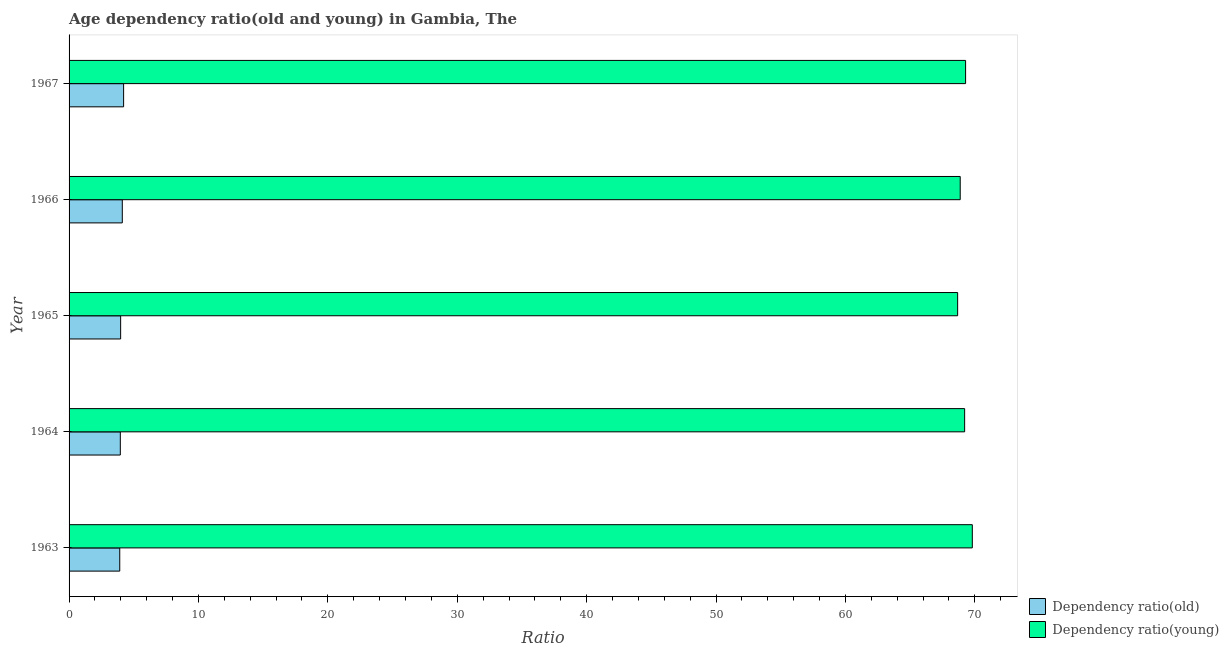How many different coloured bars are there?
Keep it short and to the point. 2. How many groups of bars are there?
Provide a succinct answer. 5. What is the label of the 3rd group of bars from the top?
Make the answer very short. 1965. In how many cases, is the number of bars for a given year not equal to the number of legend labels?
Your response must be concise. 0. What is the age dependency ratio(young) in 1966?
Your answer should be compact. 68.87. Across all years, what is the maximum age dependency ratio(young)?
Your answer should be very brief. 69.81. Across all years, what is the minimum age dependency ratio(old)?
Keep it short and to the point. 3.92. In which year was the age dependency ratio(old) maximum?
Your answer should be compact. 1967. What is the total age dependency ratio(young) in the graph?
Provide a succinct answer. 345.86. What is the difference between the age dependency ratio(old) in 1965 and that in 1966?
Provide a short and direct response. -0.13. What is the difference between the age dependency ratio(young) in 1963 and the age dependency ratio(old) in 1965?
Ensure brevity in your answer.  65.82. What is the average age dependency ratio(old) per year?
Your answer should be very brief. 4.04. In the year 1963, what is the difference between the age dependency ratio(old) and age dependency ratio(young)?
Your response must be concise. -65.89. In how many years, is the age dependency ratio(old) greater than 16 ?
Keep it short and to the point. 0. Is the age dependency ratio(young) in 1964 less than that in 1966?
Your answer should be compact. No. Is the difference between the age dependency ratio(young) in 1964 and 1966 greater than the difference between the age dependency ratio(old) in 1964 and 1966?
Ensure brevity in your answer.  Yes. What is the difference between the highest and the second highest age dependency ratio(old)?
Offer a very short reply. 0.1. In how many years, is the age dependency ratio(old) greater than the average age dependency ratio(old) taken over all years?
Provide a short and direct response. 2. What does the 2nd bar from the top in 1966 represents?
Make the answer very short. Dependency ratio(old). What does the 1st bar from the bottom in 1964 represents?
Give a very brief answer. Dependency ratio(old). How many years are there in the graph?
Your response must be concise. 5. What is the title of the graph?
Offer a very short reply. Age dependency ratio(old and young) in Gambia, The. What is the label or title of the X-axis?
Provide a short and direct response. Ratio. What is the Ratio in Dependency ratio(old) in 1963?
Your answer should be compact. 3.92. What is the Ratio of Dependency ratio(young) in 1963?
Offer a very short reply. 69.81. What is the Ratio in Dependency ratio(old) in 1964?
Provide a short and direct response. 3.96. What is the Ratio of Dependency ratio(young) in 1964?
Provide a short and direct response. 69.22. What is the Ratio in Dependency ratio(old) in 1965?
Provide a short and direct response. 3.99. What is the Ratio of Dependency ratio(young) in 1965?
Your response must be concise. 68.67. What is the Ratio in Dependency ratio(old) in 1966?
Make the answer very short. 4.11. What is the Ratio in Dependency ratio(young) in 1966?
Your answer should be compact. 68.87. What is the Ratio of Dependency ratio(old) in 1967?
Your answer should be very brief. 4.21. What is the Ratio in Dependency ratio(young) in 1967?
Your answer should be compact. 69.29. Across all years, what is the maximum Ratio of Dependency ratio(old)?
Your response must be concise. 4.21. Across all years, what is the maximum Ratio in Dependency ratio(young)?
Your answer should be very brief. 69.81. Across all years, what is the minimum Ratio of Dependency ratio(old)?
Provide a succinct answer. 3.92. Across all years, what is the minimum Ratio in Dependency ratio(young)?
Your response must be concise. 68.67. What is the total Ratio in Dependency ratio(old) in the graph?
Give a very brief answer. 20.19. What is the total Ratio of Dependency ratio(young) in the graph?
Make the answer very short. 345.86. What is the difference between the Ratio in Dependency ratio(old) in 1963 and that in 1964?
Your response must be concise. -0.04. What is the difference between the Ratio in Dependency ratio(young) in 1963 and that in 1964?
Offer a very short reply. 0.59. What is the difference between the Ratio in Dependency ratio(old) in 1963 and that in 1965?
Offer a very short reply. -0.07. What is the difference between the Ratio in Dependency ratio(young) in 1963 and that in 1965?
Your answer should be compact. 1.13. What is the difference between the Ratio of Dependency ratio(old) in 1963 and that in 1966?
Make the answer very short. -0.2. What is the difference between the Ratio in Dependency ratio(young) in 1963 and that in 1966?
Your response must be concise. 0.93. What is the difference between the Ratio of Dependency ratio(old) in 1963 and that in 1967?
Provide a succinct answer. -0.3. What is the difference between the Ratio in Dependency ratio(young) in 1963 and that in 1967?
Provide a succinct answer. 0.52. What is the difference between the Ratio in Dependency ratio(old) in 1964 and that in 1965?
Your response must be concise. -0.03. What is the difference between the Ratio of Dependency ratio(young) in 1964 and that in 1965?
Ensure brevity in your answer.  0.54. What is the difference between the Ratio of Dependency ratio(old) in 1964 and that in 1966?
Ensure brevity in your answer.  -0.15. What is the difference between the Ratio in Dependency ratio(young) in 1964 and that in 1966?
Offer a terse response. 0.34. What is the difference between the Ratio in Dependency ratio(old) in 1964 and that in 1967?
Make the answer very short. -0.25. What is the difference between the Ratio in Dependency ratio(young) in 1964 and that in 1967?
Your answer should be compact. -0.07. What is the difference between the Ratio in Dependency ratio(old) in 1965 and that in 1966?
Your response must be concise. -0.13. What is the difference between the Ratio of Dependency ratio(young) in 1965 and that in 1966?
Give a very brief answer. -0.2. What is the difference between the Ratio of Dependency ratio(old) in 1965 and that in 1967?
Your answer should be compact. -0.23. What is the difference between the Ratio in Dependency ratio(young) in 1965 and that in 1967?
Provide a succinct answer. -0.61. What is the difference between the Ratio of Dependency ratio(old) in 1966 and that in 1967?
Your answer should be very brief. -0.1. What is the difference between the Ratio in Dependency ratio(young) in 1966 and that in 1967?
Provide a succinct answer. -0.42. What is the difference between the Ratio of Dependency ratio(old) in 1963 and the Ratio of Dependency ratio(young) in 1964?
Provide a short and direct response. -65.3. What is the difference between the Ratio in Dependency ratio(old) in 1963 and the Ratio in Dependency ratio(young) in 1965?
Make the answer very short. -64.76. What is the difference between the Ratio of Dependency ratio(old) in 1963 and the Ratio of Dependency ratio(young) in 1966?
Your answer should be very brief. -64.96. What is the difference between the Ratio in Dependency ratio(old) in 1963 and the Ratio in Dependency ratio(young) in 1967?
Your answer should be compact. -65.37. What is the difference between the Ratio in Dependency ratio(old) in 1964 and the Ratio in Dependency ratio(young) in 1965?
Provide a succinct answer. -64.71. What is the difference between the Ratio of Dependency ratio(old) in 1964 and the Ratio of Dependency ratio(young) in 1966?
Provide a short and direct response. -64.91. What is the difference between the Ratio in Dependency ratio(old) in 1964 and the Ratio in Dependency ratio(young) in 1967?
Offer a terse response. -65.33. What is the difference between the Ratio in Dependency ratio(old) in 1965 and the Ratio in Dependency ratio(young) in 1966?
Your answer should be compact. -64.89. What is the difference between the Ratio in Dependency ratio(old) in 1965 and the Ratio in Dependency ratio(young) in 1967?
Ensure brevity in your answer.  -65.3. What is the difference between the Ratio of Dependency ratio(old) in 1966 and the Ratio of Dependency ratio(young) in 1967?
Your answer should be compact. -65.17. What is the average Ratio of Dependency ratio(old) per year?
Your response must be concise. 4.04. What is the average Ratio in Dependency ratio(young) per year?
Your response must be concise. 69.17. In the year 1963, what is the difference between the Ratio in Dependency ratio(old) and Ratio in Dependency ratio(young)?
Make the answer very short. -65.89. In the year 1964, what is the difference between the Ratio in Dependency ratio(old) and Ratio in Dependency ratio(young)?
Your answer should be very brief. -65.26. In the year 1965, what is the difference between the Ratio in Dependency ratio(old) and Ratio in Dependency ratio(young)?
Provide a succinct answer. -64.69. In the year 1966, what is the difference between the Ratio of Dependency ratio(old) and Ratio of Dependency ratio(young)?
Provide a short and direct response. -64.76. In the year 1967, what is the difference between the Ratio of Dependency ratio(old) and Ratio of Dependency ratio(young)?
Provide a short and direct response. -65.07. What is the ratio of the Ratio in Dependency ratio(young) in 1963 to that in 1964?
Make the answer very short. 1.01. What is the ratio of the Ratio of Dependency ratio(old) in 1963 to that in 1965?
Offer a very short reply. 0.98. What is the ratio of the Ratio in Dependency ratio(young) in 1963 to that in 1965?
Offer a terse response. 1.02. What is the ratio of the Ratio in Dependency ratio(old) in 1963 to that in 1966?
Provide a short and direct response. 0.95. What is the ratio of the Ratio of Dependency ratio(young) in 1963 to that in 1966?
Offer a terse response. 1.01. What is the ratio of the Ratio in Dependency ratio(old) in 1963 to that in 1967?
Your answer should be very brief. 0.93. What is the ratio of the Ratio of Dependency ratio(young) in 1963 to that in 1967?
Provide a short and direct response. 1.01. What is the ratio of the Ratio of Dependency ratio(young) in 1964 to that in 1965?
Offer a terse response. 1.01. What is the ratio of the Ratio in Dependency ratio(old) in 1964 to that in 1966?
Your answer should be compact. 0.96. What is the ratio of the Ratio in Dependency ratio(old) in 1964 to that in 1967?
Your response must be concise. 0.94. What is the ratio of the Ratio of Dependency ratio(young) in 1964 to that in 1967?
Offer a terse response. 1. What is the ratio of the Ratio in Dependency ratio(old) in 1965 to that in 1966?
Your answer should be very brief. 0.97. What is the ratio of the Ratio in Dependency ratio(old) in 1965 to that in 1967?
Provide a short and direct response. 0.95. What is the ratio of the Ratio of Dependency ratio(old) in 1966 to that in 1967?
Offer a terse response. 0.98. What is the ratio of the Ratio of Dependency ratio(young) in 1966 to that in 1967?
Provide a succinct answer. 0.99. What is the difference between the highest and the second highest Ratio in Dependency ratio(old)?
Offer a terse response. 0.1. What is the difference between the highest and the second highest Ratio of Dependency ratio(young)?
Your response must be concise. 0.52. What is the difference between the highest and the lowest Ratio of Dependency ratio(old)?
Provide a short and direct response. 0.3. What is the difference between the highest and the lowest Ratio in Dependency ratio(young)?
Provide a succinct answer. 1.13. 